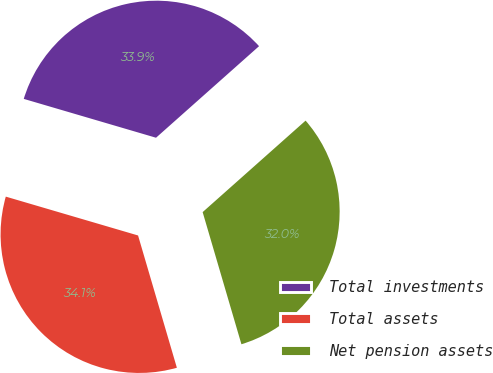Convert chart to OTSL. <chart><loc_0><loc_0><loc_500><loc_500><pie_chart><fcel>Total investments<fcel>Total assets<fcel>Net pension assets<nl><fcel>33.89%<fcel>34.09%<fcel>32.02%<nl></chart> 